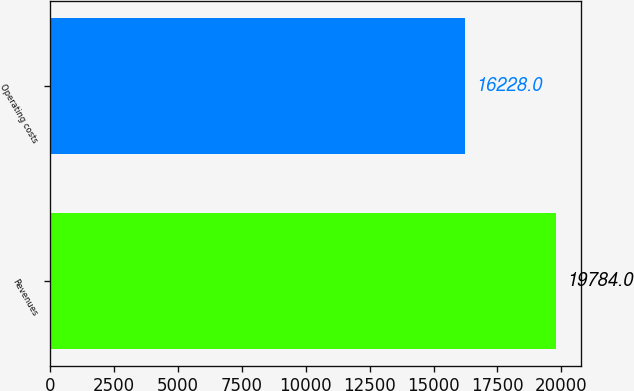<chart> <loc_0><loc_0><loc_500><loc_500><bar_chart><fcel>Revenues<fcel>Operating costs<nl><fcel>19784<fcel>16228<nl></chart> 